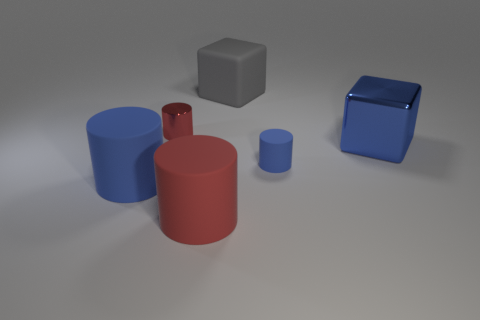Add 3 small red metal cylinders. How many objects exist? 9 Subtract all cylinders. How many objects are left? 2 Add 3 blue matte things. How many blue matte things exist? 5 Subtract 0 green balls. How many objects are left? 6 Subtract all big shiny cubes. Subtract all big blue cylinders. How many objects are left? 4 Add 3 big blue cylinders. How many big blue cylinders are left? 4 